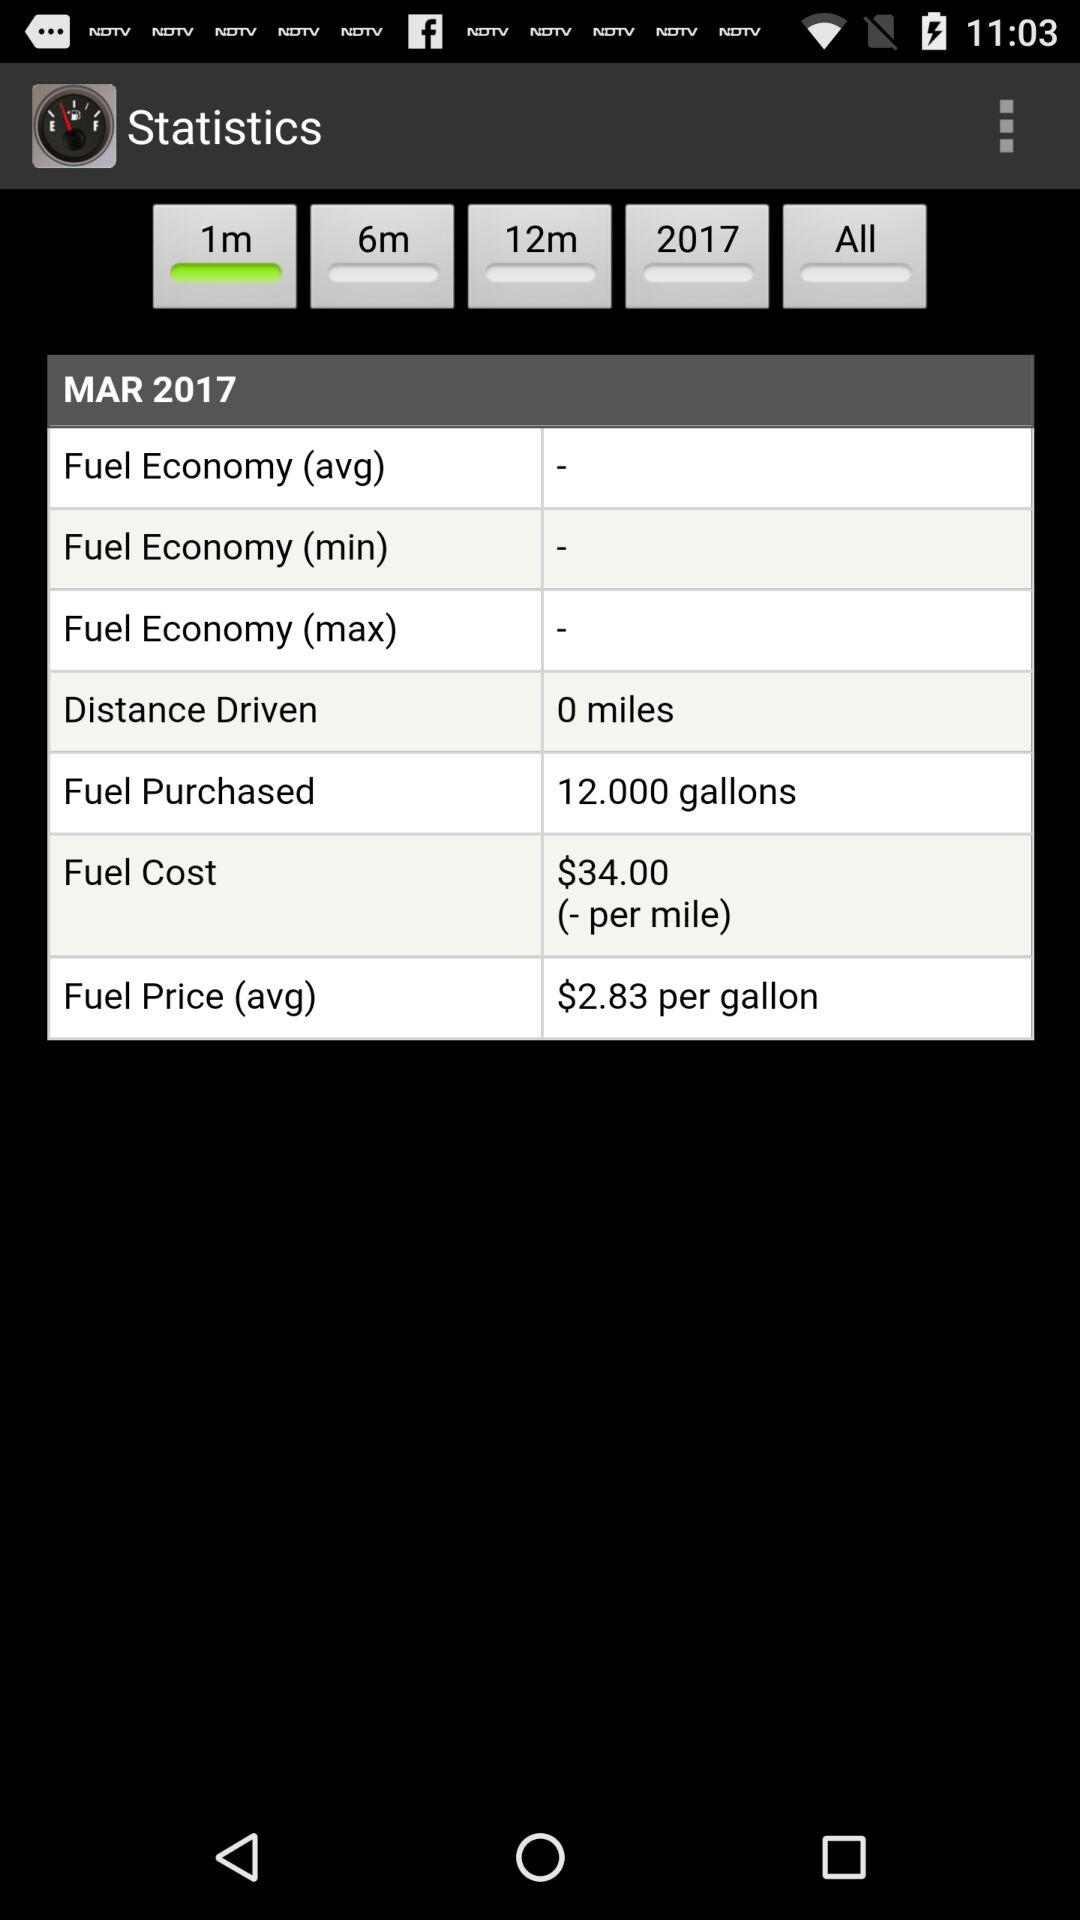What is the total distance driven? The total distance driven is 0 miles. 